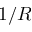Convert formula to latex. <formula><loc_0><loc_0><loc_500><loc_500>1 / R</formula> 